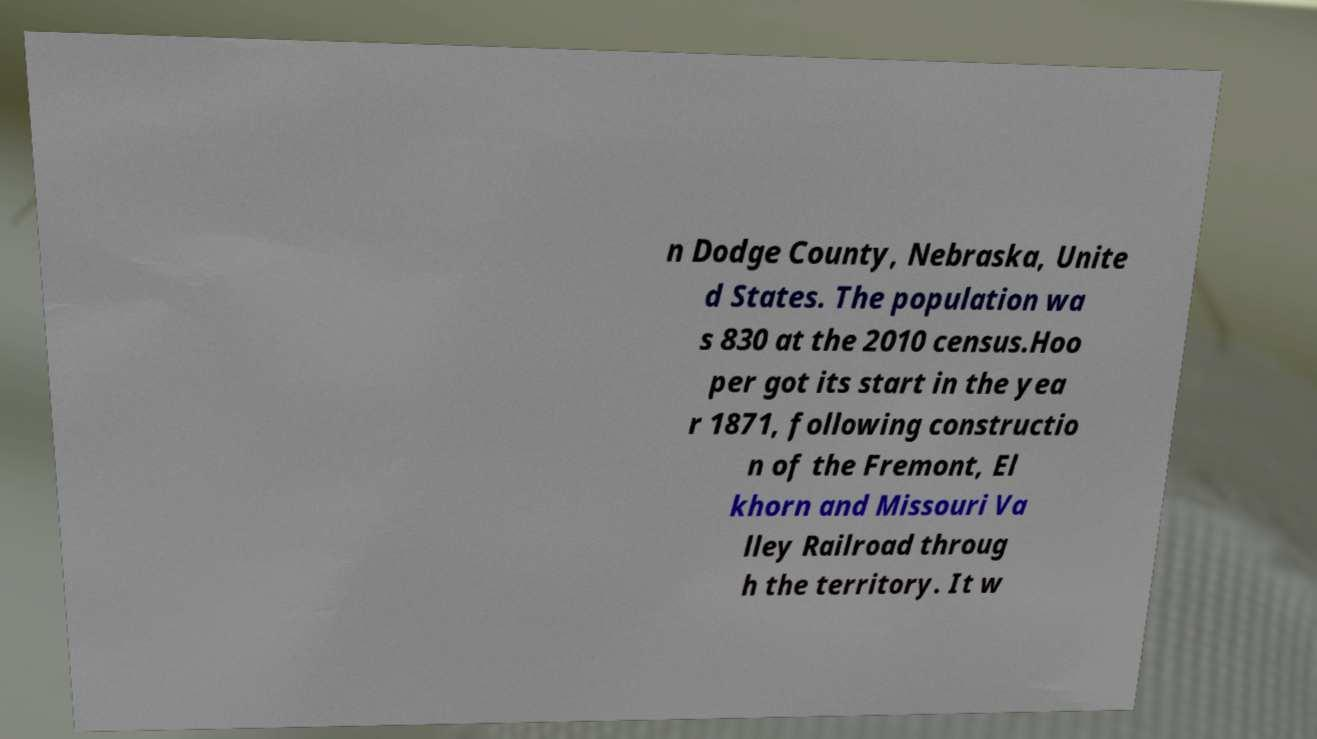Could you extract and type out the text from this image? n Dodge County, Nebraska, Unite d States. The population wa s 830 at the 2010 census.Hoo per got its start in the yea r 1871, following constructio n of the Fremont, El khorn and Missouri Va lley Railroad throug h the territory. It w 